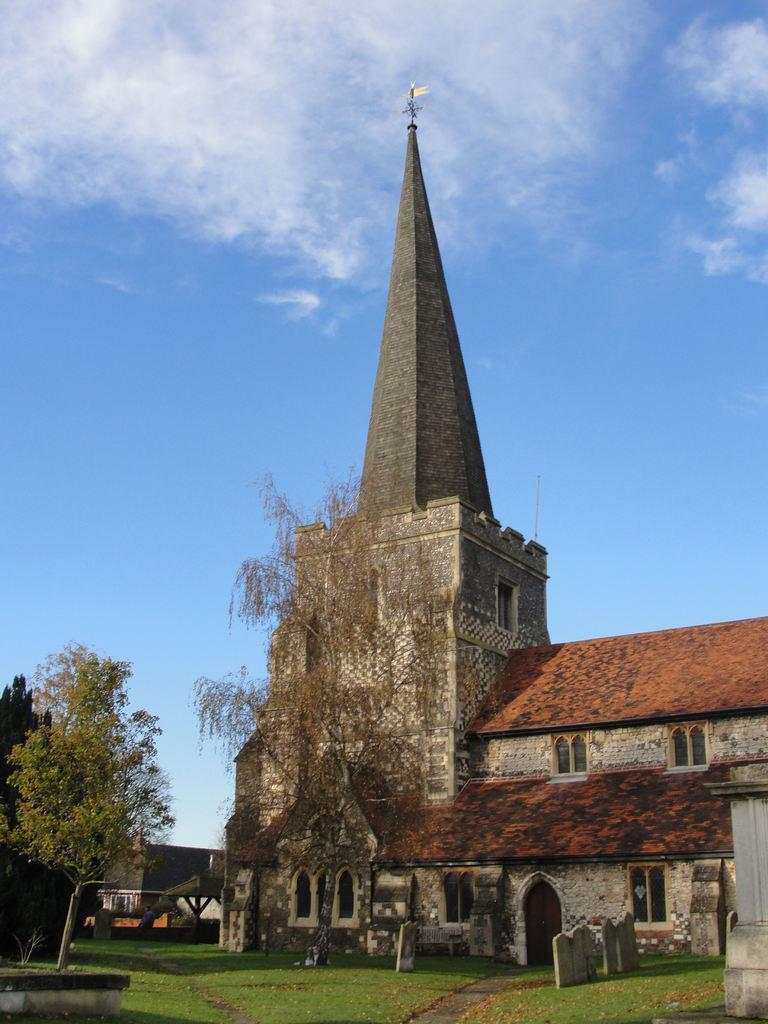What type of vegetation can be seen in the image? There is grass in the image. What type of structures are present in the image? There are headstones, trees, and buildings in the image. What is visible in the sky in the image? There are clouds visible in the image. Can you tell me how many cacti are present in the image? There are no cacti present in the image; it features grass, headstones, trees, and buildings. What type of fight is taking place in the image? There is no fight present in the image; it is a scene with grass, headstones, trees, buildings, and clouds. 